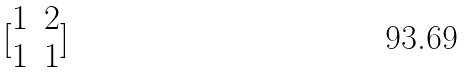Convert formula to latex. <formula><loc_0><loc_0><loc_500><loc_500>[ \begin{matrix} 1 & 2 \\ 1 & 1 \end{matrix} ]</formula> 